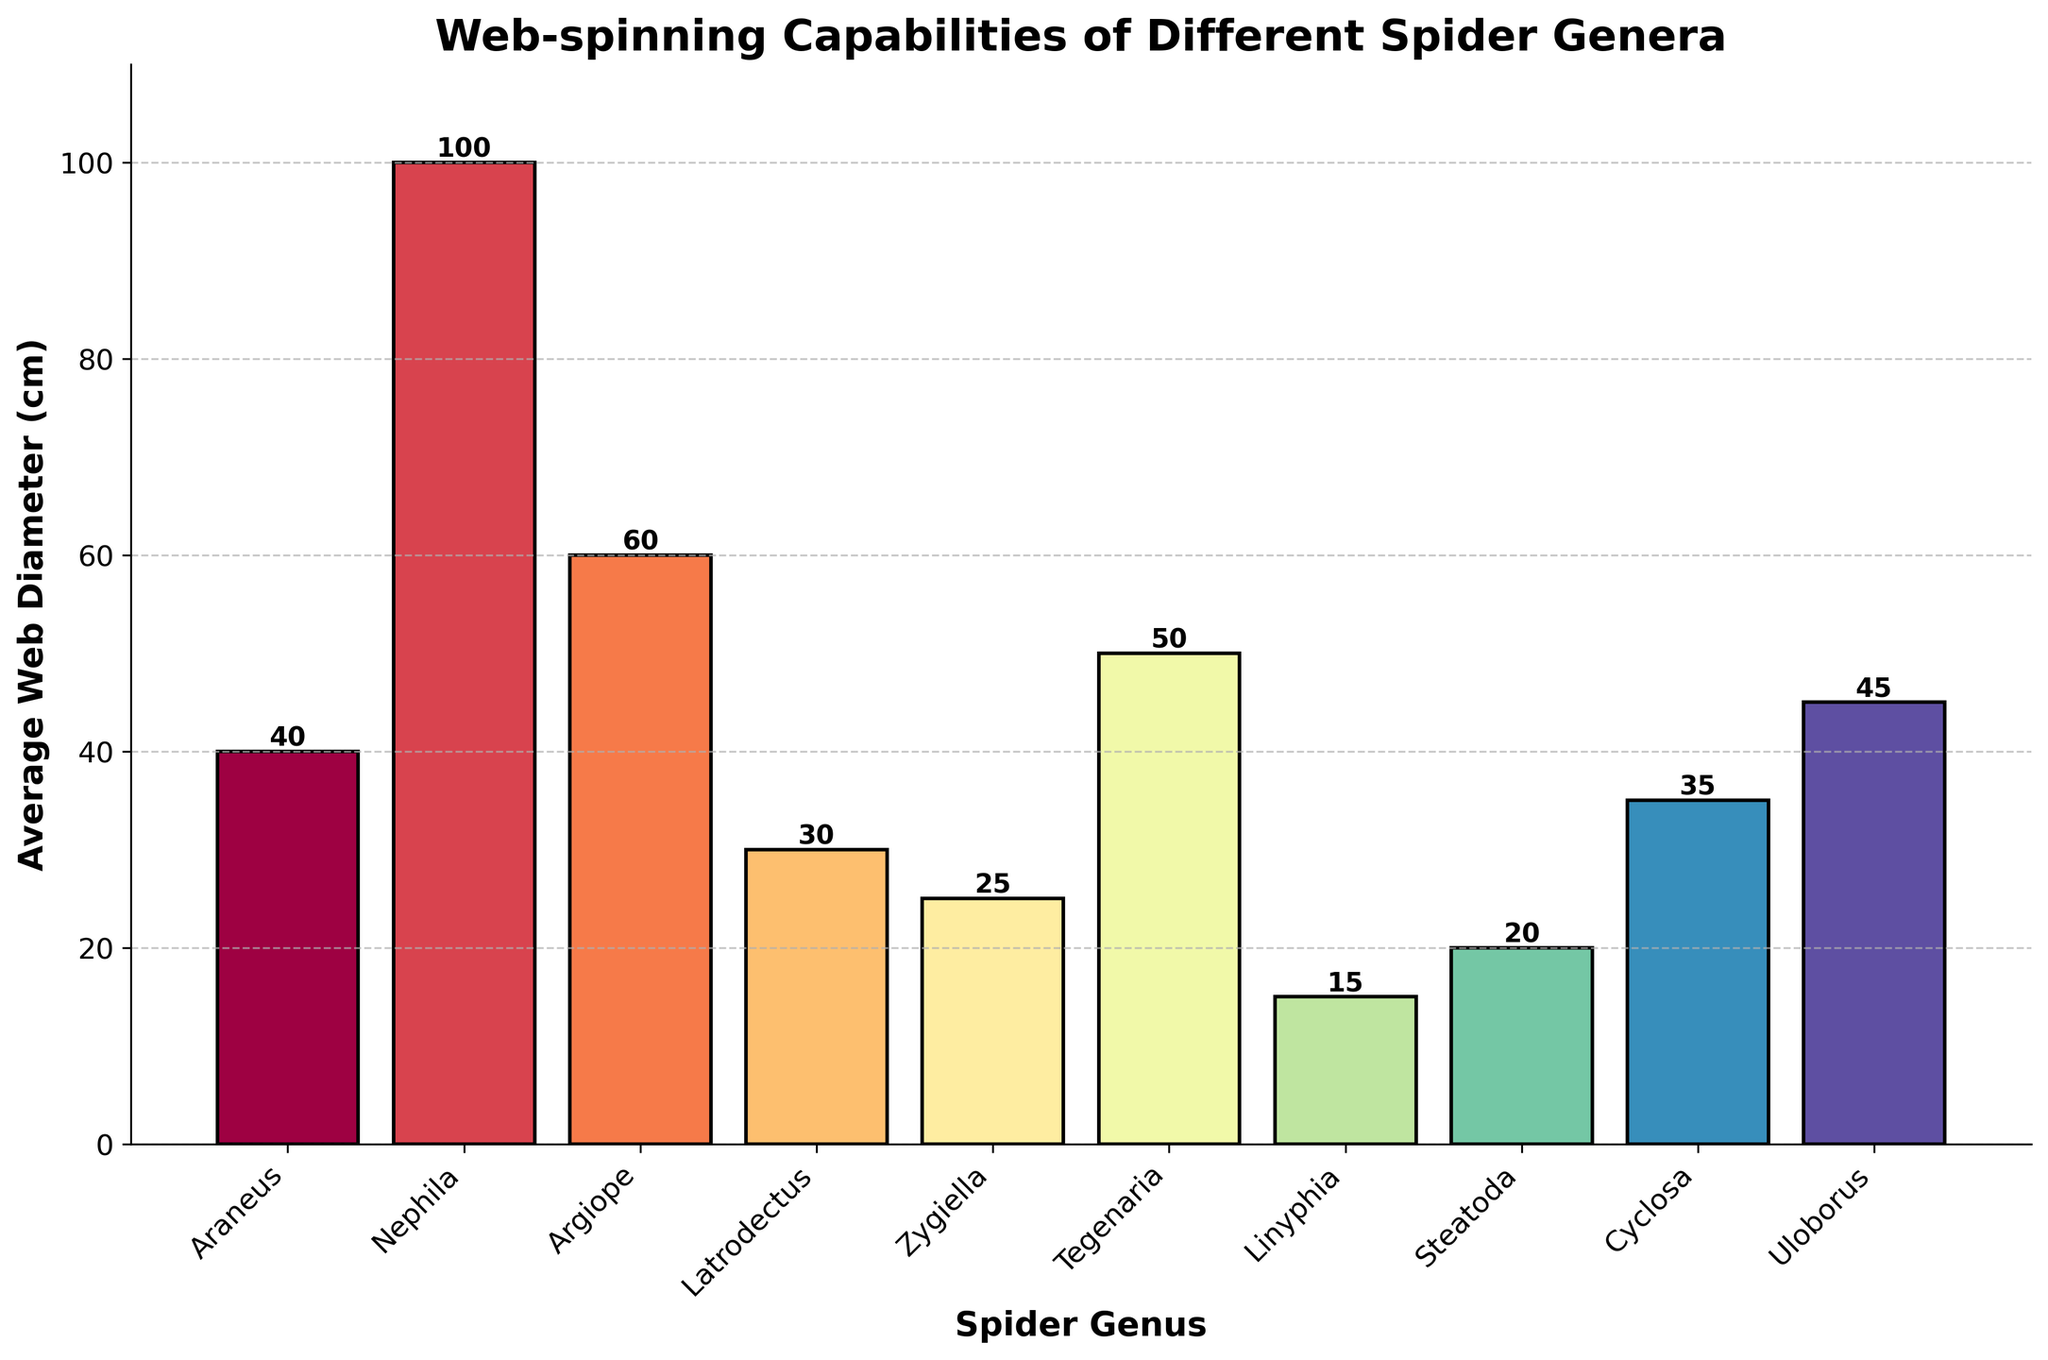Which spider genus has the largest average web diameter? By observing the heights of the bars, Nephila has the tallest bar, indicating it has the largest average web diameter.
Answer: Nephila Compare the average web diameters of Araneus and Latrodectus. Which one is larger and by how much? The bar for Araneus reaches 40 cm, while the bar for Latrodectus reaches 30 cm. Therefore, subtracting the value for Latrodectus from Araneus gives 40 cm - 30 cm = 10 cm. Araneus has a larger web diameter by 10 cm.
Answer: Araneus, by 10 cm What is the average web diameter for the genus with the shortest web? By observing the heights of the bars, Linyphia has the shortest bar which measures 15 cm.
Answer: 15 cm Calculate the total web diameters if you sum the values of Uloborus and Zygiella. Uloborus has an average web diameter of 45 cm, and Zygiella has 25 cm. Summing these values gives 45 cm + 25 cm = 70 cm.
Answer: 70 cm How much larger is Nephila's average web diameter compared to Steatoda? Nephila's web diameter is 100 cm, and Steatoda's is 20 cm. The difference is 100 cm - 20 cm = 80 cm.
Answer: 80 cm Which genus has an average web diameter closest to 50 cm? Observing the heights, Tegenaria's bar reaches closest to 50 cm.
Answer: Tegenaria What is the combined average web diameter of all spider genera with an average web diameter above 40 cm? The relevant genera are Nephila (100 cm), Argiope (60 cm), Tegenaria (50 cm), and Uloborus (45 cm). Summing these values: 100 cm + 60 cm + 50 cm + 45 cm = 255 cm.
Answer: 255 cm Rank the top three spider genera by their average web diameter. By observing the heights of the bars, the top three are Nephila (100 cm), Argiope (60 cm), and Tegenaria (50 cm).
Answer: Nephila, Argiope, Tegenaria What percentage is Zygiella's average web diameter compared to Nephila's? Zygiella's web diameter is 25 cm, and Nephila's is 100 cm. The percentage is calculated as (25/100) * 100 = 25%.
Answer: 25% Which spider genus has a web diameter slightly less than Cyclosa? Cyclosa's bar reaches 35 cm, and Araneus, just below, reaches 30 cm.
Answer: Latrodectus 